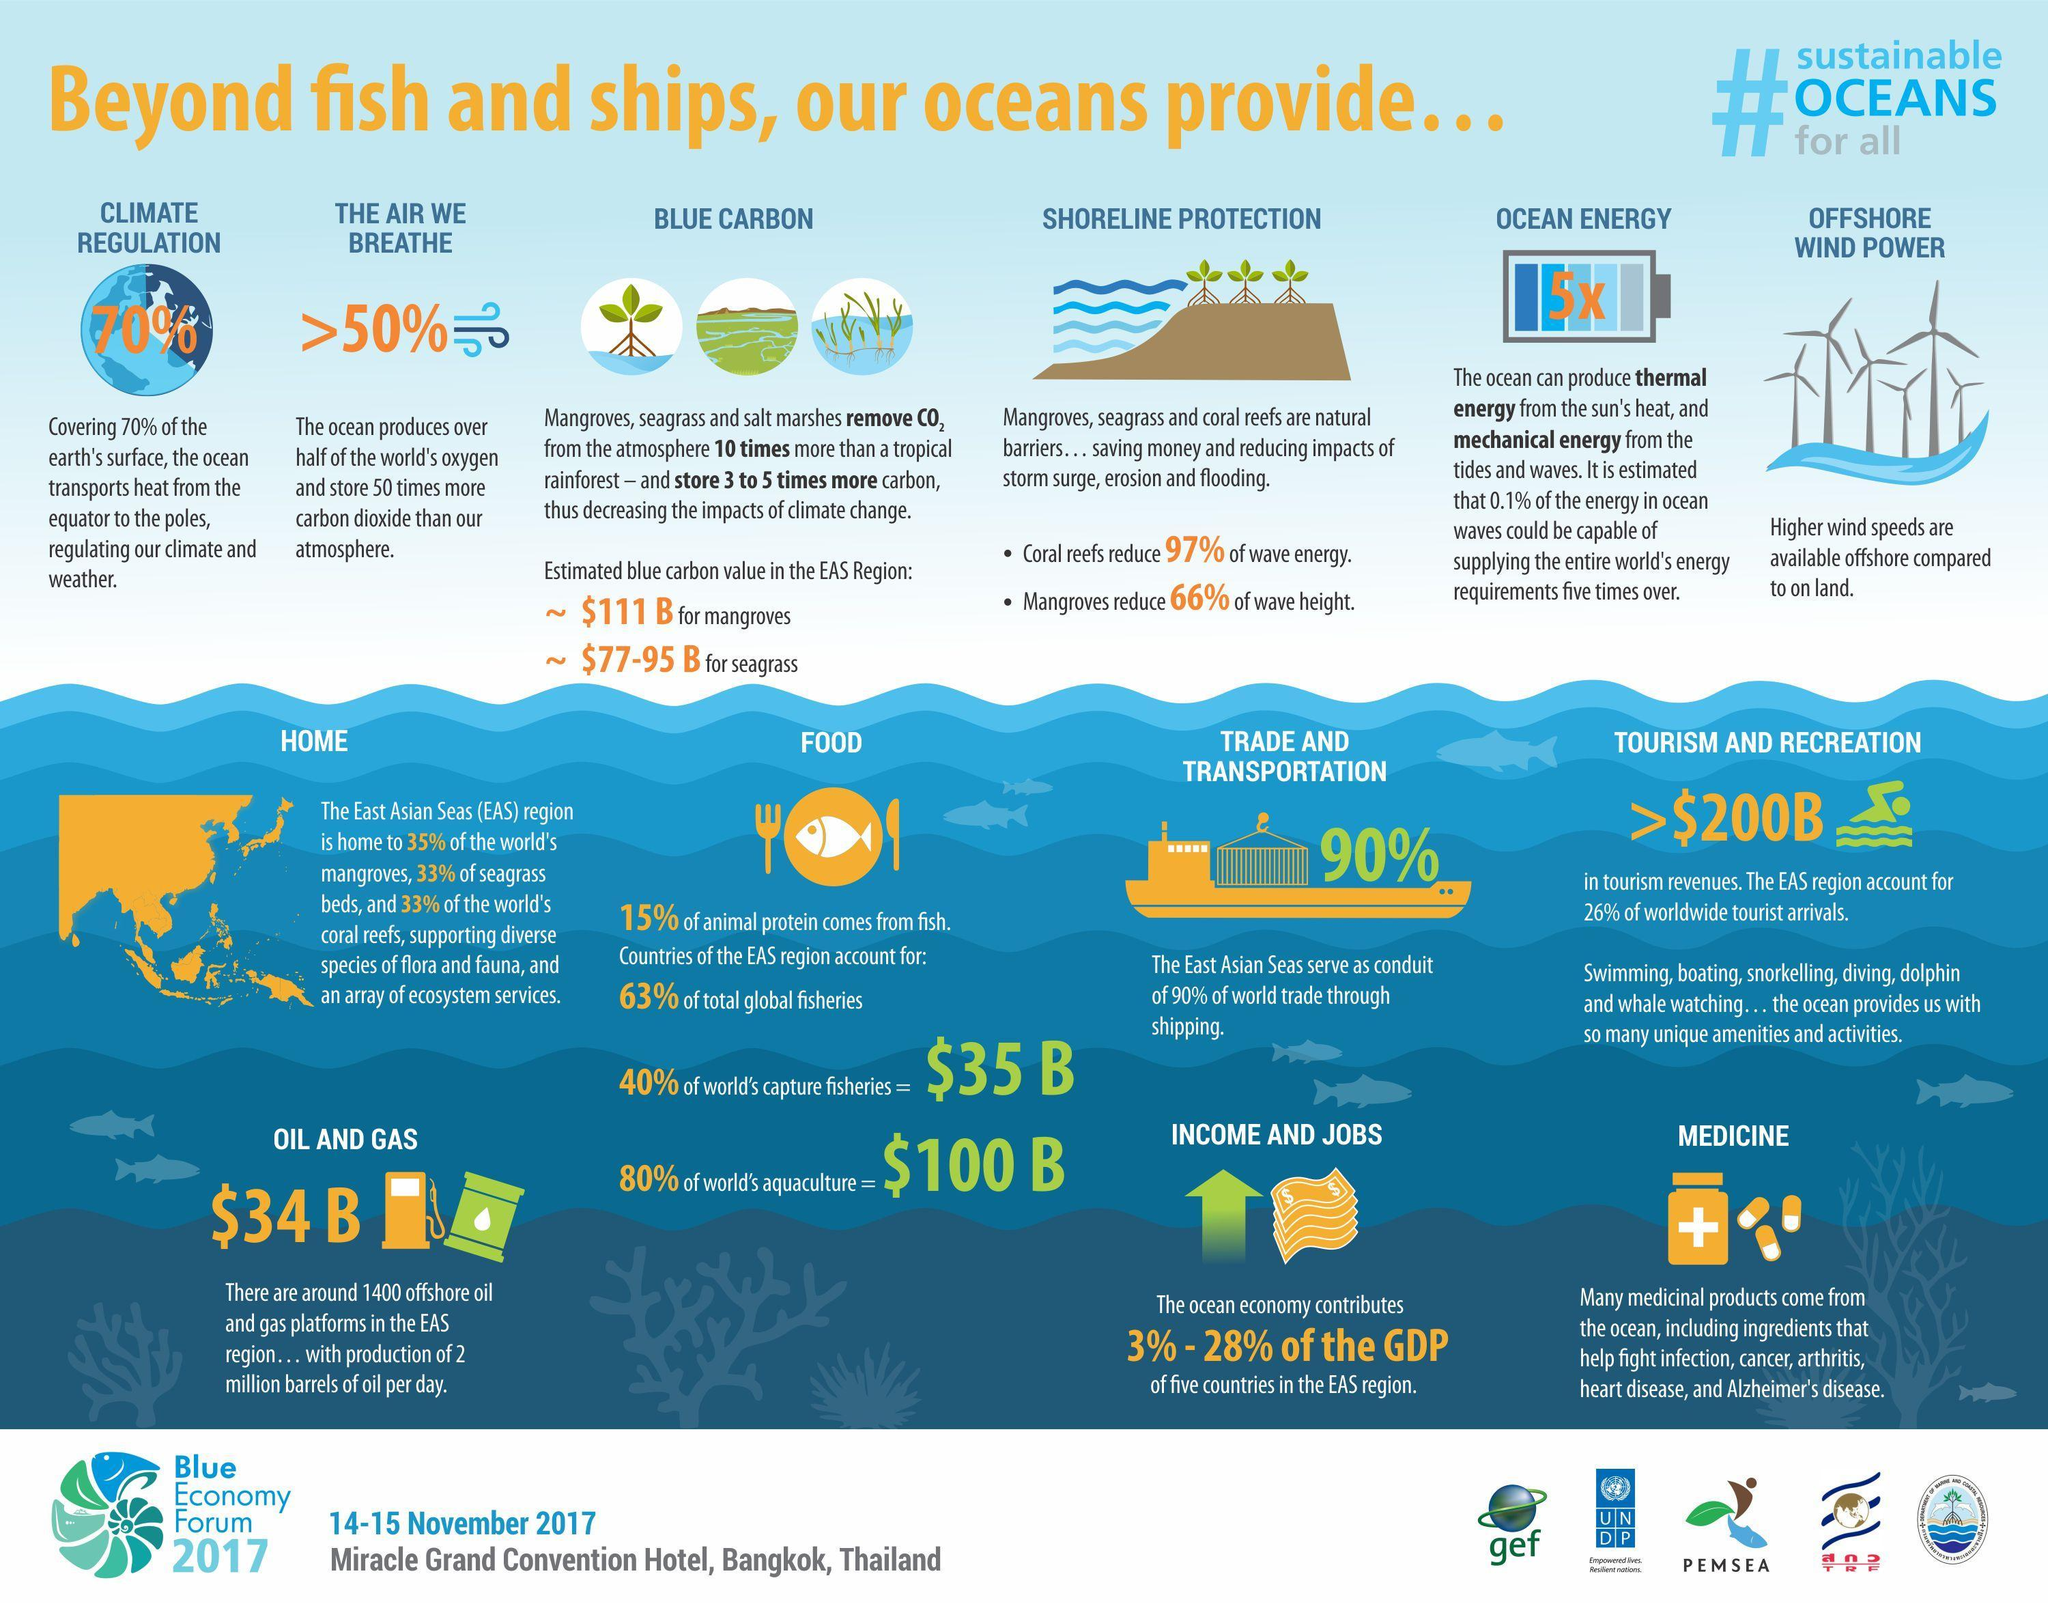How many other things are provided by oceans other than fish and ships ?
Answer the question with a short phrase. 13 What is percentage of climate regulation provided by oceans, 50%, 70%, or 66% ? 70% Which two things that helps in removing CO2 and provide shoreline protection? Mangroves, seagrass 